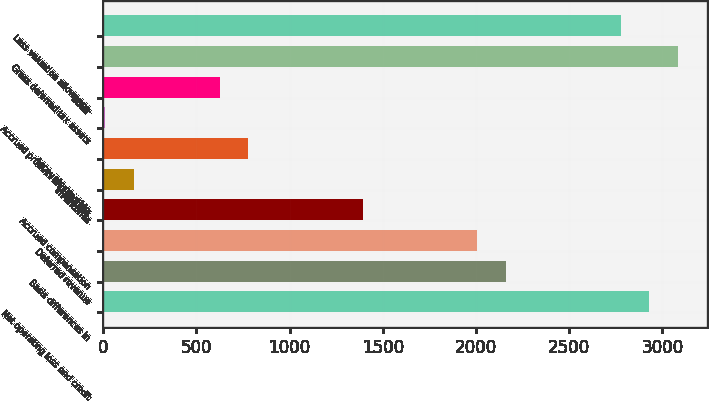<chart> <loc_0><loc_0><loc_500><loc_500><bar_chart><fcel>Net operating loss and credit<fcel>Basis differences in<fcel>Deferred revenue<fcel>Accrued compensation<fcel>Inventories<fcel>Accounts payable<fcel>Accrued product and process<fcel>Other<fcel>Gross deferred tax assets<fcel>Less valuation allowance<nl><fcel>2929.4<fcel>2161.4<fcel>2007.8<fcel>1393.4<fcel>164.6<fcel>779<fcel>11<fcel>625.4<fcel>3083<fcel>2775.8<nl></chart> 